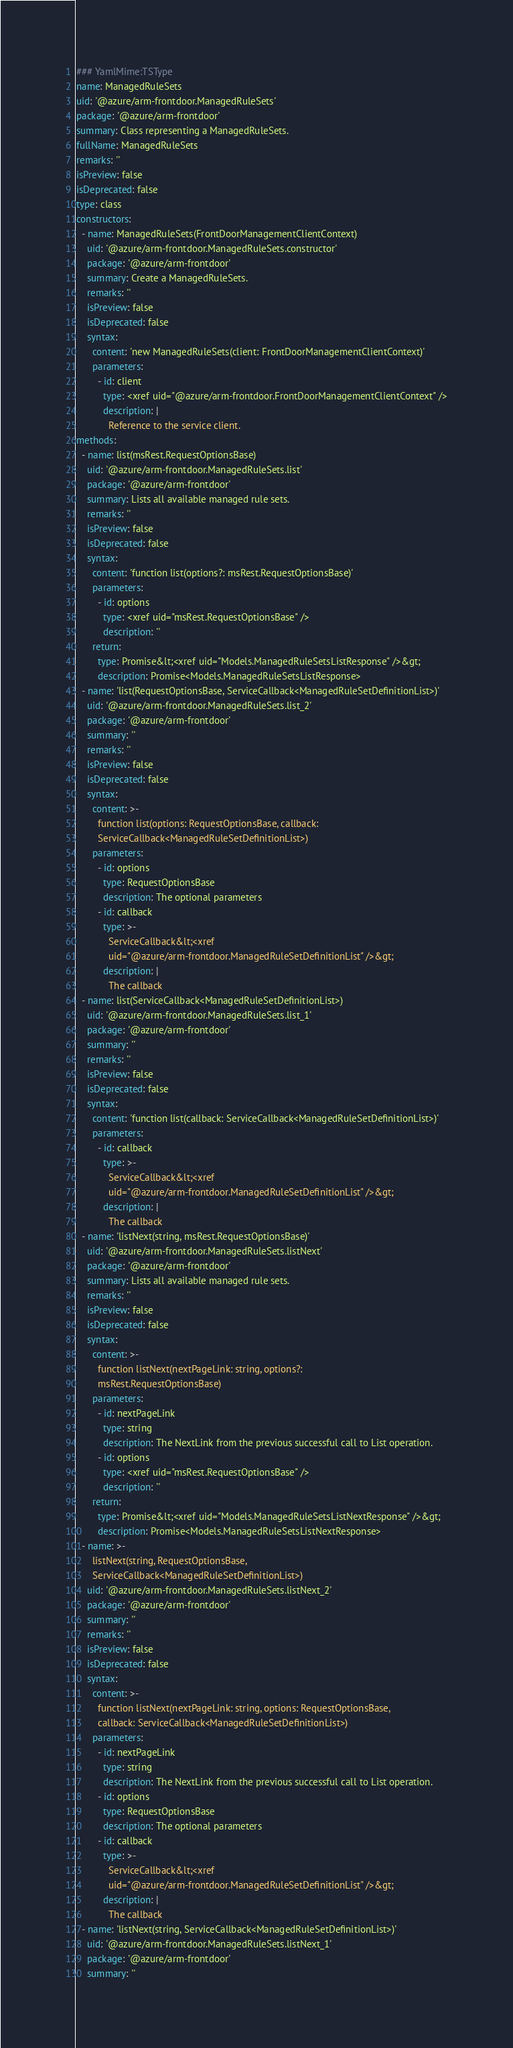Convert code to text. <code><loc_0><loc_0><loc_500><loc_500><_YAML_>### YamlMime:TSType
name: ManagedRuleSets
uid: '@azure/arm-frontdoor.ManagedRuleSets'
package: '@azure/arm-frontdoor'
summary: Class representing a ManagedRuleSets.
fullName: ManagedRuleSets
remarks: ''
isPreview: false
isDeprecated: false
type: class
constructors:
  - name: ManagedRuleSets(FrontDoorManagementClientContext)
    uid: '@azure/arm-frontdoor.ManagedRuleSets.constructor'
    package: '@azure/arm-frontdoor'
    summary: Create a ManagedRuleSets.
    remarks: ''
    isPreview: false
    isDeprecated: false
    syntax:
      content: 'new ManagedRuleSets(client: FrontDoorManagementClientContext)'
      parameters:
        - id: client
          type: <xref uid="@azure/arm-frontdoor.FrontDoorManagementClientContext" />
          description: |
            Reference to the service client.
methods:
  - name: list(msRest.RequestOptionsBase)
    uid: '@azure/arm-frontdoor.ManagedRuleSets.list'
    package: '@azure/arm-frontdoor'
    summary: Lists all available managed rule sets.
    remarks: ''
    isPreview: false
    isDeprecated: false
    syntax:
      content: 'function list(options?: msRest.RequestOptionsBase)'
      parameters:
        - id: options
          type: <xref uid="msRest.RequestOptionsBase" />
          description: ''
      return:
        type: Promise&lt;<xref uid="Models.ManagedRuleSetsListResponse" />&gt;
        description: Promise<Models.ManagedRuleSetsListResponse>
  - name: 'list(RequestOptionsBase, ServiceCallback<ManagedRuleSetDefinitionList>)'
    uid: '@azure/arm-frontdoor.ManagedRuleSets.list_2'
    package: '@azure/arm-frontdoor'
    summary: ''
    remarks: ''
    isPreview: false
    isDeprecated: false
    syntax:
      content: >-
        function list(options: RequestOptionsBase, callback:
        ServiceCallback<ManagedRuleSetDefinitionList>)
      parameters:
        - id: options
          type: RequestOptionsBase
          description: The optional parameters
        - id: callback
          type: >-
            ServiceCallback&lt;<xref
            uid="@azure/arm-frontdoor.ManagedRuleSetDefinitionList" />&gt;
          description: |
            The callback
  - name: list(ServiceCallback<ManagedRuleSetDefinitionList>)
    uid: '@azure/arm-frontdoor.ManagedRuleSets.list_1'
    package: '@azure/arm-frontdoor'
    summary: ''
    remarks: ''
    isPreview: false
    isDeprecated: false
    syntax:
      content: 'function list(callback: ServiceCallback<ManagedRuleSetDefinitionList>)'
      parameters:
        - id: callback
          type: >-
            ServiceCallback&lt;<xref
            uid="@azure/arm-frontdoor.ManagedRuleSetDefinitionList" />&gt;
          description: |
            The callback
  - name: 'listNext(string, msRest.RequestOptionsBase)'
    uid: '@azure/arm-frontdoor.ManagedRuleSets.listNext'
    package: '@azure/arm-frontdoor'
    summary: Lists all available managed rule sets.
    remarks: ''
    isPreview: false
    isDeprecated: false
    syntax:
      content: >-
        function listNext(nextPageLink: string, options?:
        msRest.RequestOptionsBase)
      parameters:
        - id: nextPageLink
          type: string
          description: The NextLink from the previous successful call to List operation.
        - id: options
          type: <xref uid="msRest.RequestOptionsBase" />
          description: ''
      return:
        type: Promise&lt;<xref uid="Models.ManagedRuleSetsListNextResponse" />&gt;
        description: Promise<Models.ManagedRuleSetsListNextResponse>
  - name: >-
      listNext(string, RequestOptionsBase,
      ServiceCallback<ManagedRuleSetDefinitionList>)
    uid: '@azure/arm-frontdoor.ManagedRuleSets.listNext_2'
    package: '@azure/arm-frontdoor'
    summary: ''
    remarks: ''
    isPreview: false
    isDeprecated: false
    syntax:
      content: >-
        function listNext(nextPageLink: string, options: RequestOptionsBase,
        callback: ServiceCallback<ManagedRuleSetDefinitionList>)
      parameters:
        - id: nextPageLink
          type: string
          description: The NextLink from the previous successful call to List operation.
        - id: options
          type: RequestOptionsBase
          description: The optional parameters
        - id: callback
          type: >-
            ServiceCallback&lt;<xref
            uid="@azure/arm-frontdoor.ManagedRuleSetDefinitionList" />&gt;
          description: |
            The callback
  - name: 'listNext(string, ServiceCallback<ManagedRuleSetDefinitionList>)'
    uid: '@azure/arm-frontdoor.ManagedRuleSets.listNext_1'
    package: '@azure/arm-frontdoor'
    summary: ''</code> 